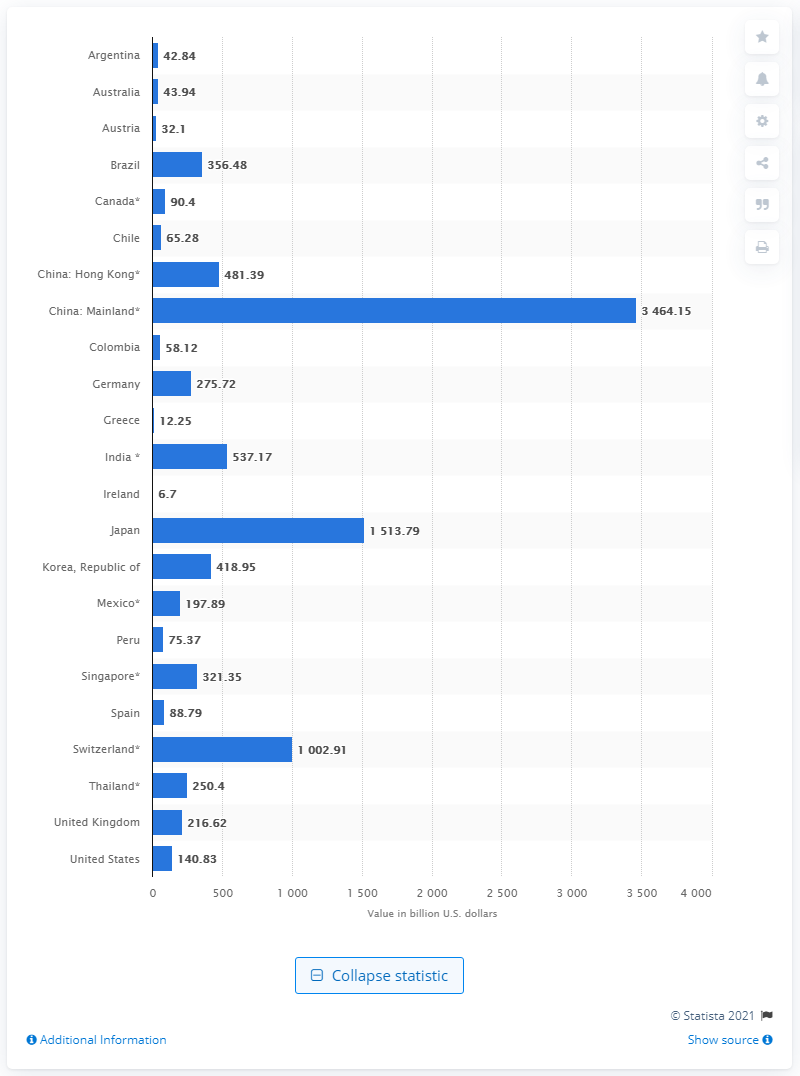Highlight a few significant elements in this photo. According to the information provided, Japan and Switzerland had a total of 1513.79 U.S. dollars in reserves. In August 2020, China had a total of 34,641.50 US dollars in reserves. 